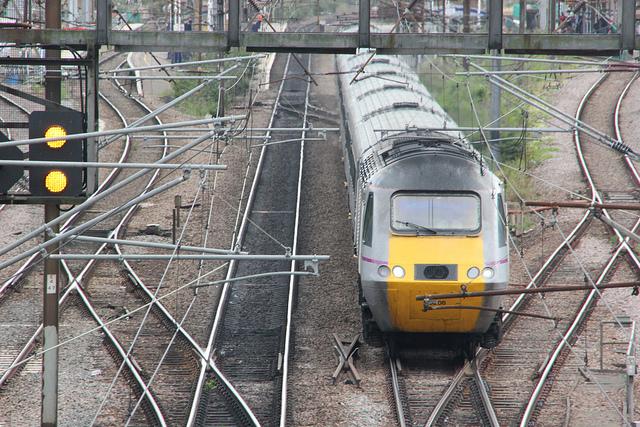Are the signal light and the front of the train the same color?
Keep it brief. Yes. Which track is the straightest?
Keep it brief. Middle track. What color is the signal light?
Write a very short answer. Yellow. 